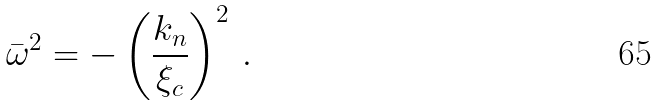<formula> <loc_0><loc_0><loc_500><loc_500>\bar { \omega } ^ { 2 } = - \left ( \frac { k _ { n } } { \xi _ { c } } \right ) ^ { 2 } \, .</formula> 